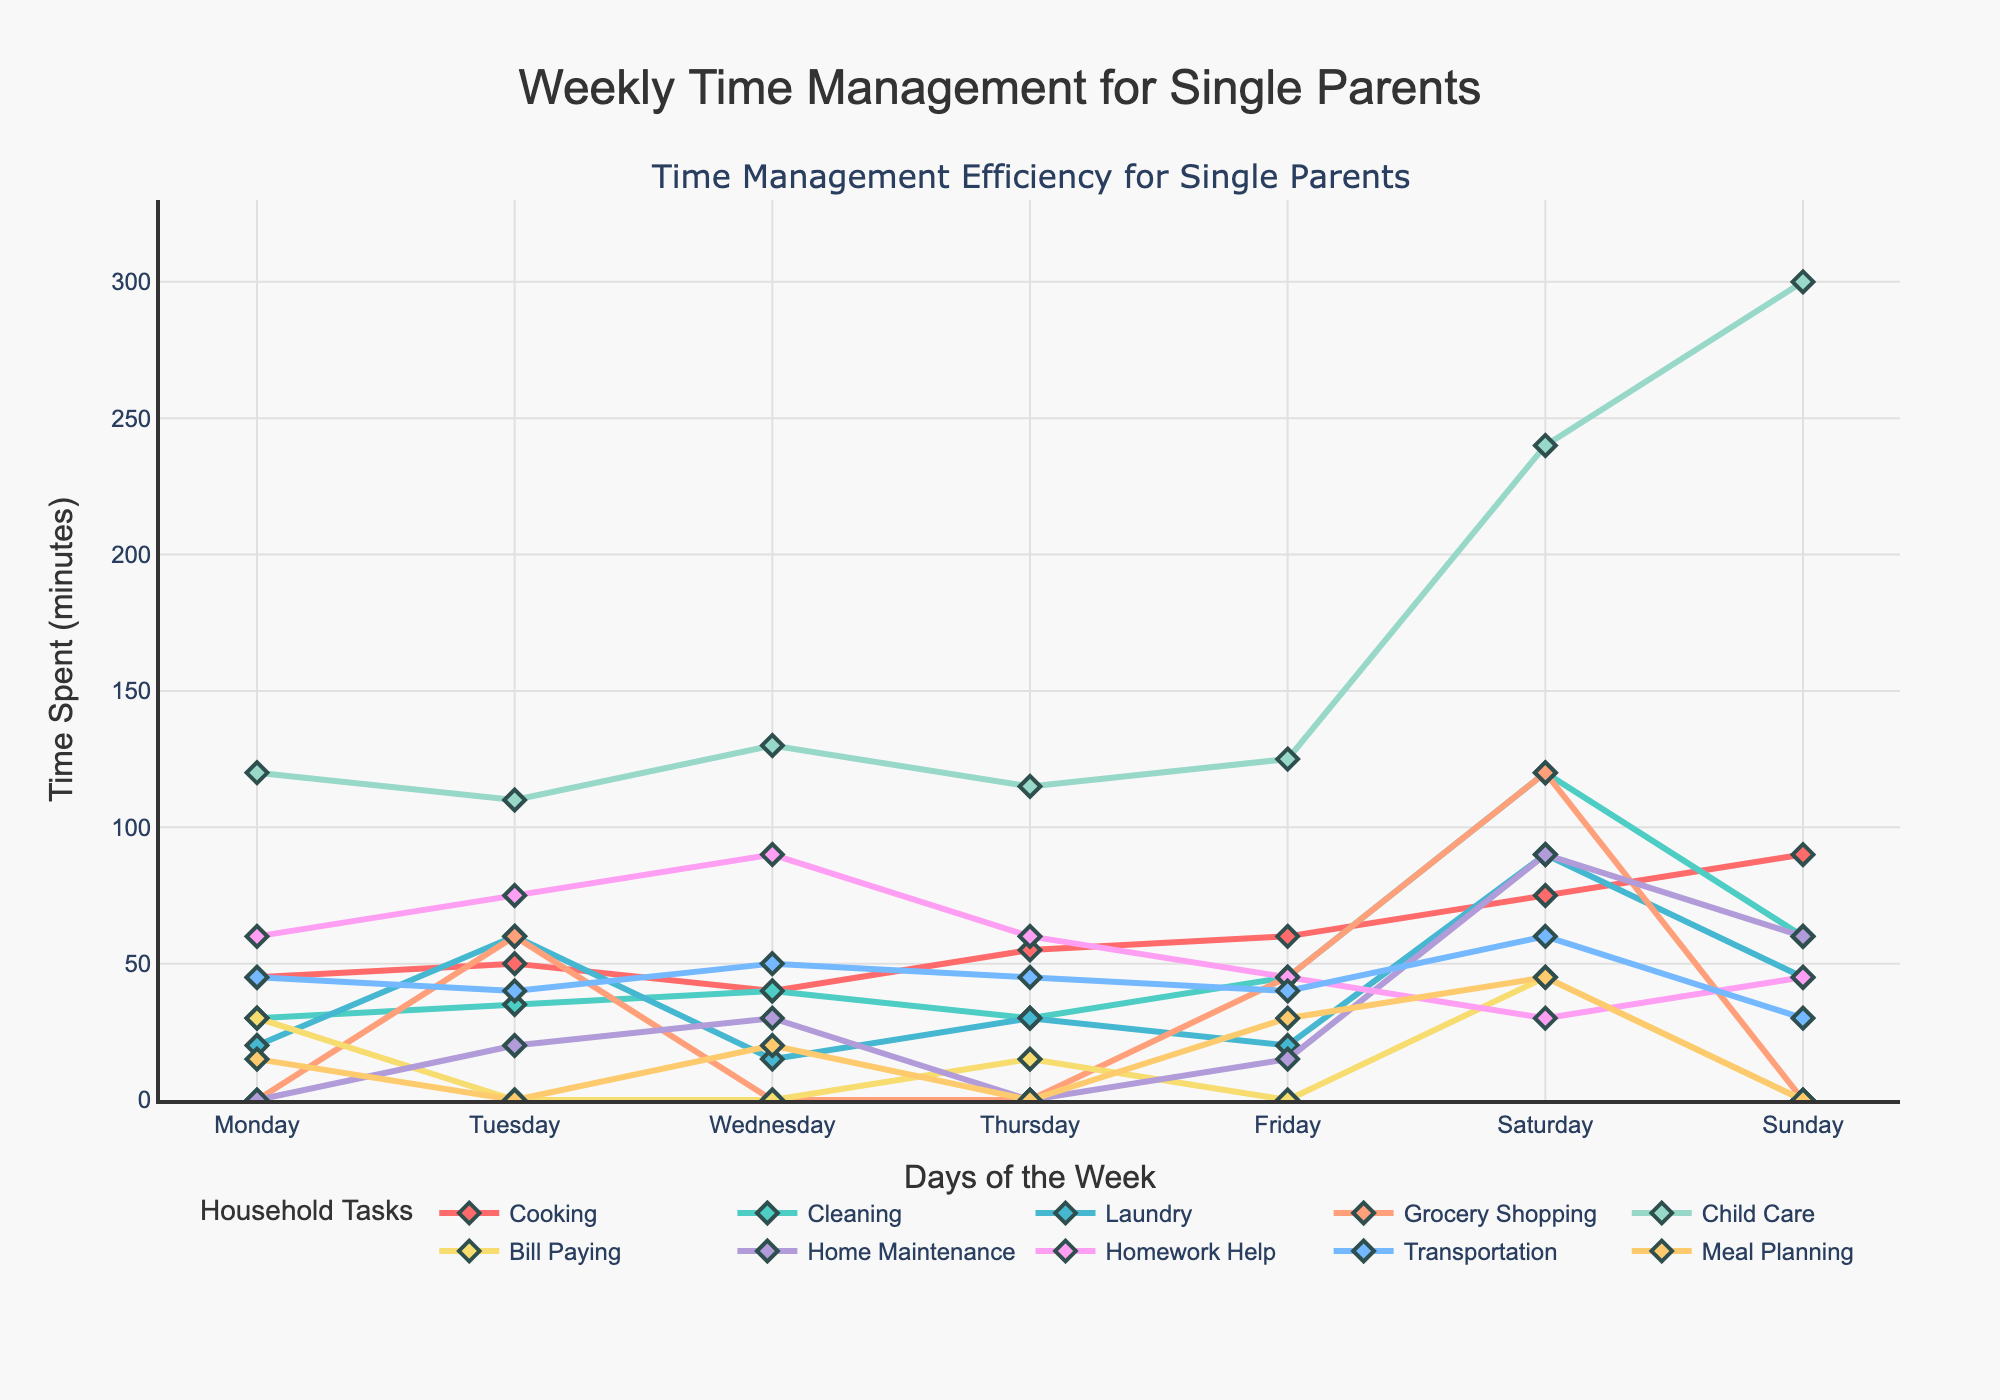What's the total time spent cooking over the weekend? Add the time spent cooking on Saturday (75 minutes) and Sunday (90 minutes): 75 + 90 = 165 minutes.
Answer: 165 minutes Which task required the most time on Wednesday? Look at the highest point on Wednesday. The task with the highest time spent is Homework Help with 90 minutes.
Answer: Homework Help How much more time is spent on child care on Sunday compared to Friday? Subtract the time spent on Friday from the time spent on Sunday. For Child Care: 300 minutes (Sunday) - 125 minutes (Friday) = 175 minutes more on Sunday.
Answer: 175 minutes On which day is Cleaning time the least? Find the smallest value in the Cleaning category. Cleaning time is least on Monday (30 minutes).
Answer: Monday What's the average time spent on transportation throughout the week? Sum the daily times for transportation and divide by the number of days: (45+40+50+45+40+60+30)/7 = 310/7 ≈ 44.29 minutes.
Answer: 44.29 minutes How does the time spent meal planning change throughout the week? Observe the Meal Planning line plot. It starts at 15 minutes on Monday, drops to 0 on Tuesday, goes back up to 20 minutes on Wednesday, drops to 0 again on Thursday, rises to 30 minutes on Friday, peaks at 45 minutes on Saturday, and falls to 0 on Sunday.
Answer: Fluctuates Which day had the highest overall task time combined? Sum each day's total time for all tasks and compare. Saturday has the highest overall combined task time with 805 minutes.
Answer: Saturday What is the difference in time spent doing laundry between Tuesday and Wednesday? Subtract the laundry time on Wednesday from Tuesday: 60 minutes (Tuesday) - 15 minutes (Wednesday) = 45 minutes.
Answer: 45 minutes What's the sum of the time spent on Home Maintenance, Child Care, and Cleaning on Saturday? Add the Saturday times for these tasks: 90 (Home Maintenance) + 240 (Child Care) + 120 (Cleaning) = 450 minutes.
Answer: 450 minutes 